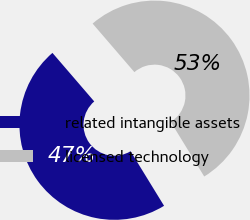Convert chart to OTSL. <chart><loc_0><loc_0><loc_500><loc_500><pie_chart><fcel>related intangible assets<fcel>licensed technology<nl><fcel>47.45%<fcel>52.55%<nl></chart> 